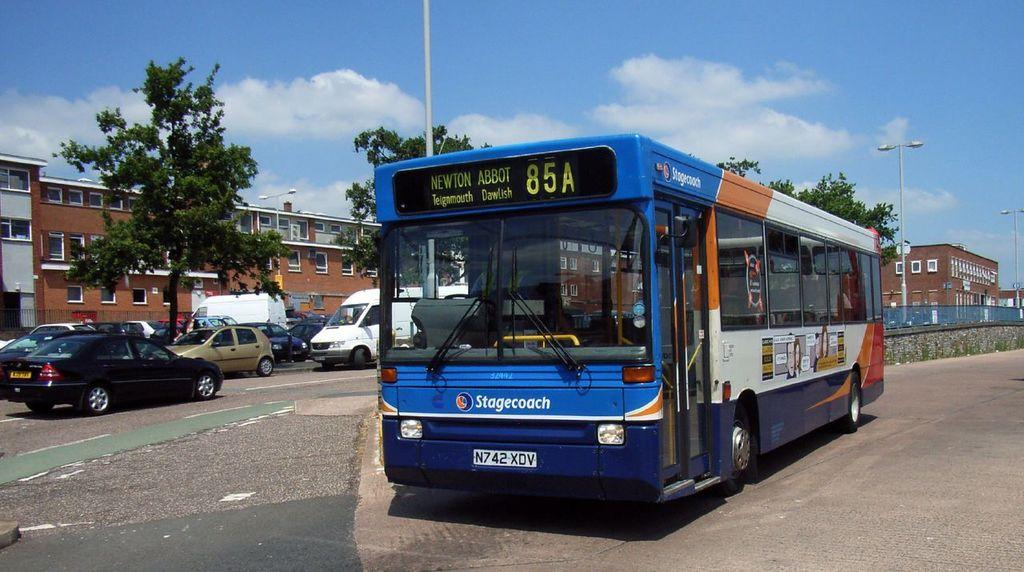What type of vehicles can be seen parked on the road in the image? There are cars and a bus parked on the road in the image. What can be seen in the background of the image? There are buildings and trees visible in the background of the image. What is the condition of the sky in the image? The sky is cloudy in the image. What type of toothbrush is the father using in the image? There is no father or toothbrush present in the image. What degree does the person holding the degree have in the image? There is no person holding a degree present in the image. 